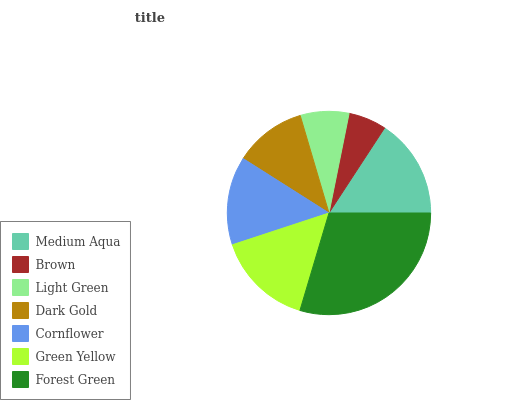Is Brown the minimum?
Answer yes or no. Yes. Is Forest Green the maximum?
Answer yes or no. Yes. Is Light Green the minimum?
Answer yes or no. No. Is Light Green the maximum?
Answer yes or no. No. Is Light Green greater than Brown?
Answer yes or no. Yes. Is Brown less than Light Green?
Answer yes or no. Yes. Is Brown greater than Light Green?
Answer yes or no. No. Is Light Green less than Brown?
Answer yes or no. No. Is Cornflower the high median?
Answer yes or no. Yes. Is Cornflower the low median?
Answer yes or no. Yes. Is Green Yellow the high median?
Answer yes or no. No. Is Light Green the low median?
Answer yes or no. No. 